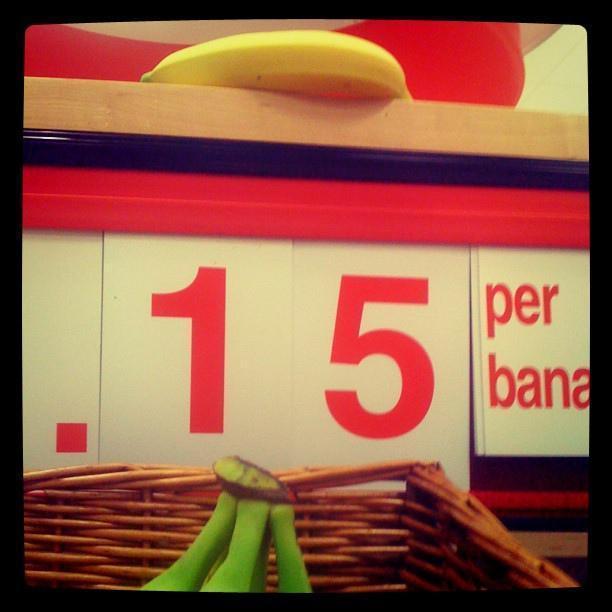How many bananas are in the photo?
Give a very brief answer. 4. 